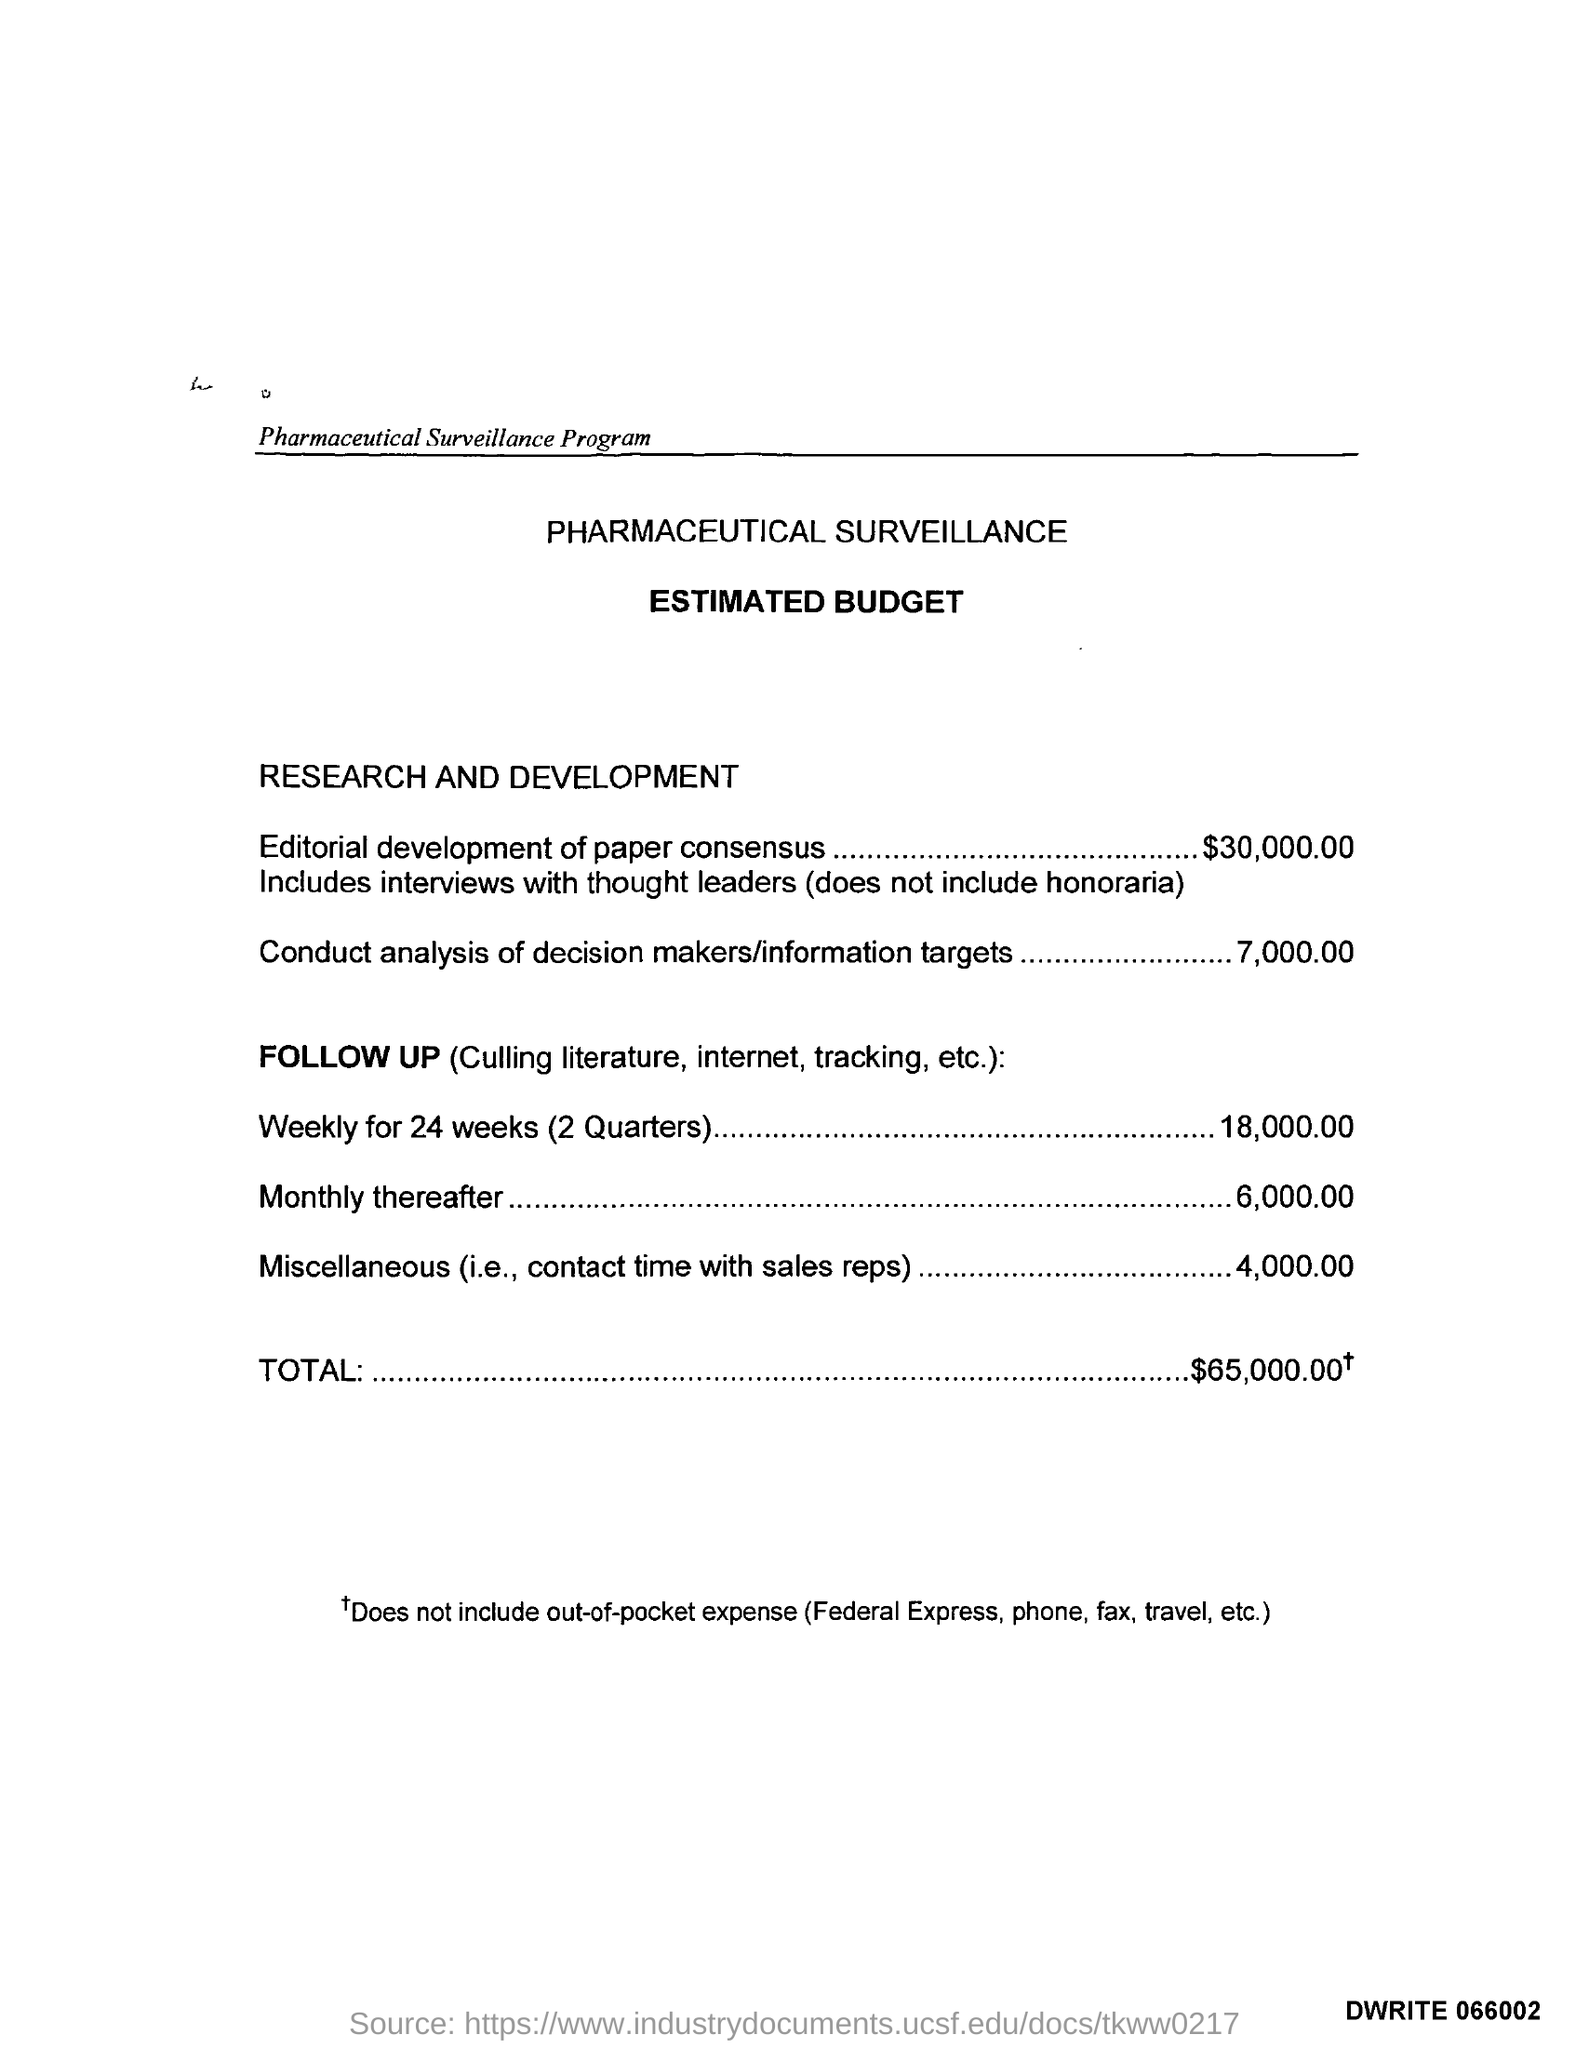Point out several critical features in this image. The estimated budget for conducting an analysis of decision-makers and information targets is $7,000.00. According to pharmaceutical surveillance, the total estimated budget is $65,000.00 and... The estimated budget for miscellaneous expenses, including contact time with sales representatives, is $4,000. The estimated budget for monthly follow-up surveillance is 6,000. The estimated budget for 24 weeks (2 quarters) is $18,000. 